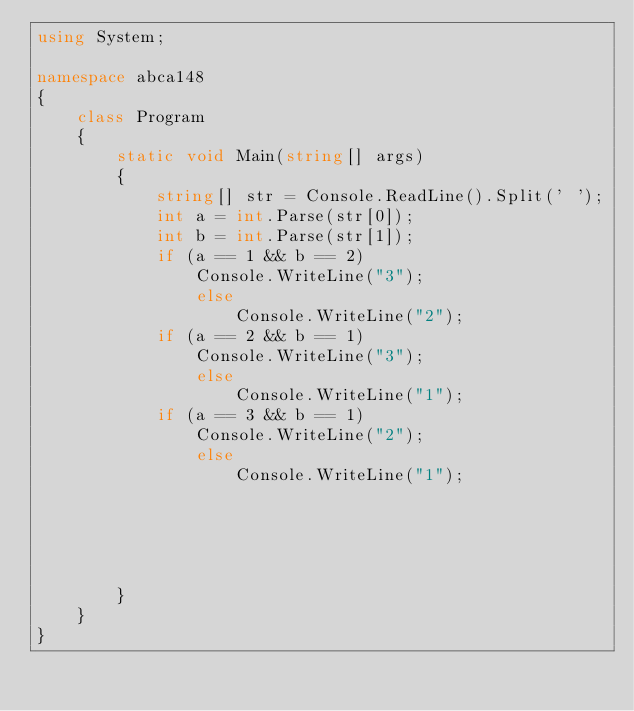Convert code to text. <code><loc_0><loc_0><loc_500><loc_500><_C#_>using System;

namespace abca148
{
    class Program
    {
        static void Main(string[] args)
        {
            string[] str = Console.ReadLine().Split(' ');
            int a = int.Parse(str[0]);
            int b = int.Parse(str[1]);
            if (a == 1 && b == 2)
                Console.WriteLine("3");
                else
                    Console.WriteLine("2");
            if (a == 2 && b == 1)
                Console.WriteLine("3");
                else
                    Console.WriteLine("1");
            if (a == 3 && b == 1)
                Console.WriteLine("2");
                else
                    Console.WriteLine("1");


 


        }
    }
}
</code> 